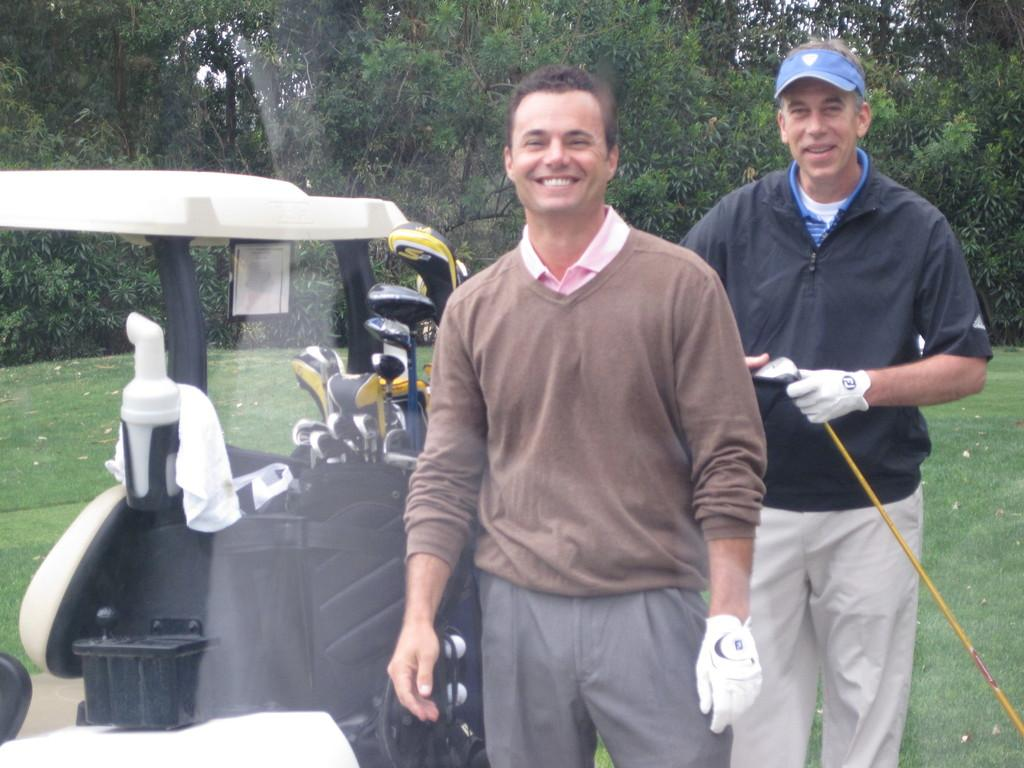How many people are in the image? There are two people in the image. What is the facial expression of the people in the image? The people are smiling. What can be seen on the ground in the image? There is a vehicle on the ground in the image. What is visible in the background of the image? There are trees in the background of the image. How many dolls are sitting on the tail of the vehicle in the image? There are no dolls or tails present in the image. 